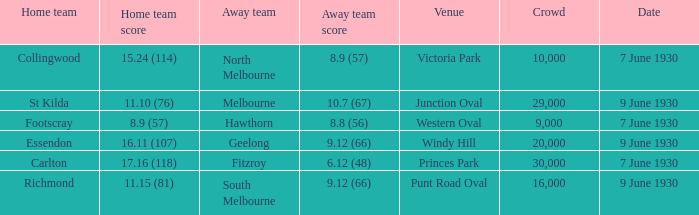Where did the away team score 8.9 (57)? Victoria Park. 